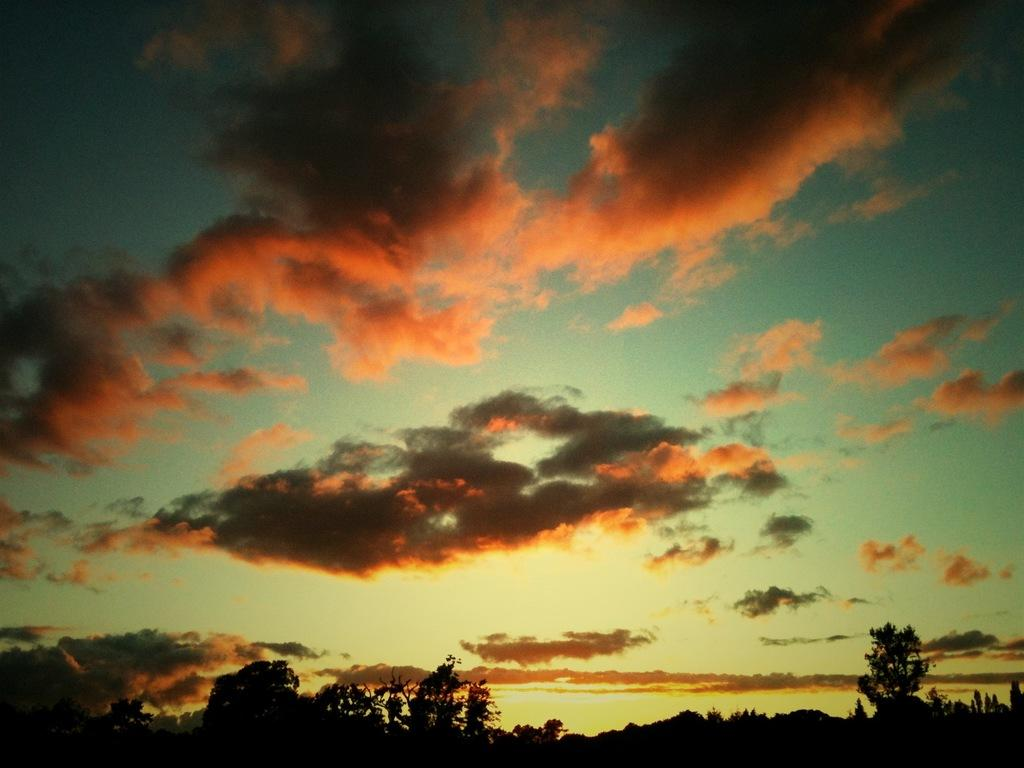What colors of the clouds in the sky? There are red and black clouds in the sky. What can be seen on the ground in the image? Trees are visible in the image. Is there a stage for a performance in the image? There is no mention of a stage in the provided facts, so it cannot be determined if there is one in the image. Can you see a kitty playing among the trees? There is no mention of a kitty in the provided facts, so it cannot be determined if there is one in the image. 